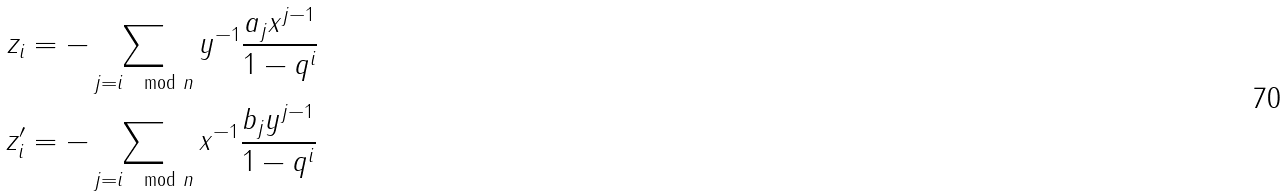Convert formula to latex. <formula><loc_0><loc_0><loc_500><loc_500>z _ { i } & = - \sum _ { j = i \mod n } y ^ { - 1 } \frac { a _ { j } x ^ { j - 1 } } { 1 - q ^ { i } } \\ z ^ { \prime } _ { i } & = - \sum _ { j = i \mod n } x ^ { - 1 } \frac { b _ { j } y ^ { j - 1 } } { 1 - q ^ { i } }</formula> 